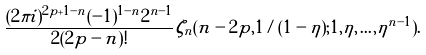<formula> <loc_0><loc_0><loc_500><loc_500>\frac { ( 2 \pi i ) ^ { 2 p + 1 - n } ( - 1 ) ^ { 1 - n } 2 ^ { n - 1 } } { 2 ( 2 p - n ) ! } \zeta _ { n } ( n - 2 p , 1 / ( 1 - \eta ) ; 1 , \eta , \dots , \eta ^ { n - 1 } ) .</formula> 